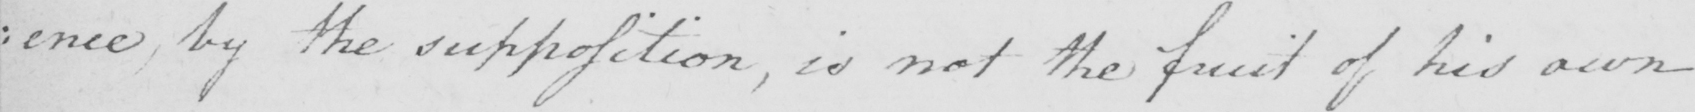What does this handwritten line say? : ence , by the supposition , is not the fruit of his own 